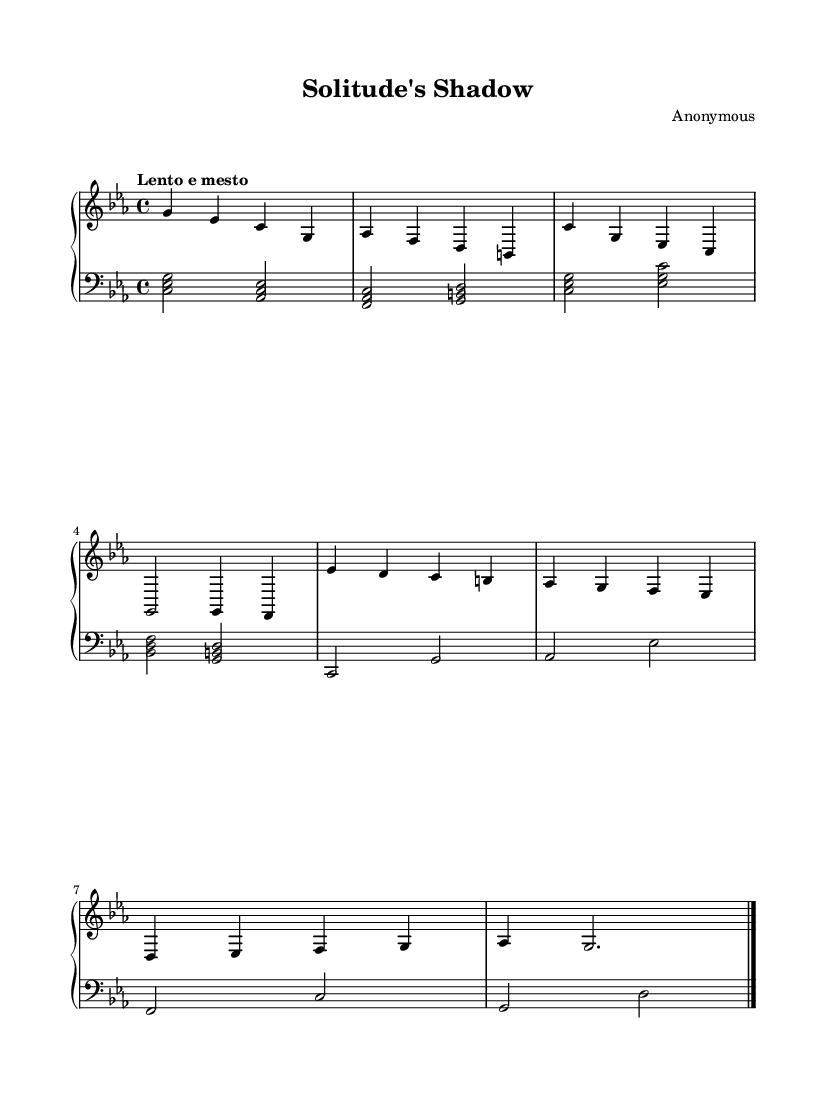What is the key signature of this music? The key signature is C minor, which contains three flats (B flat, E flat, and A flat). This can be determined by looking at the key signature indicated at the beginning of the staff.
Answer: C minor What is the time signature of this piece? The time signature displayed in the sheet music is 4/4, meaning there are four beats per measure and the quarter note gets one beat. This can be seen at the start of the staff.
Answer: 4/4 What tempo marking is indicated in the score? The tempo marking "Lento e mesto" suggests a slow and mournful pace. This marking is typically located at the beginning of the score, providing direction on how quickly the piece should be played.
Answer: Lento e mesto How many measures are in the piece? By counting each group of notes and the bar lines in the score, there are a total of eight measures present. Each measure is separated by a vertical line, making it easy to tally them.
Answer: 8 What is the lowest note present in the left hand? The lowest note in the left hand of the sheet music is C, which can be found in the bass clef on the first chord of the left-hand staff. This note is played below middle C.
Answer: C Identify the primary theme conveyed by the dynamics and articulation in this piece. The piece conveys a melancholic and reflective theme, characterized by soft dynamics (indicated by the absence of accent markings) and smooth, legato articulations between the notes. This reflects the overall mood of isolation.
Answer: Melancholic 